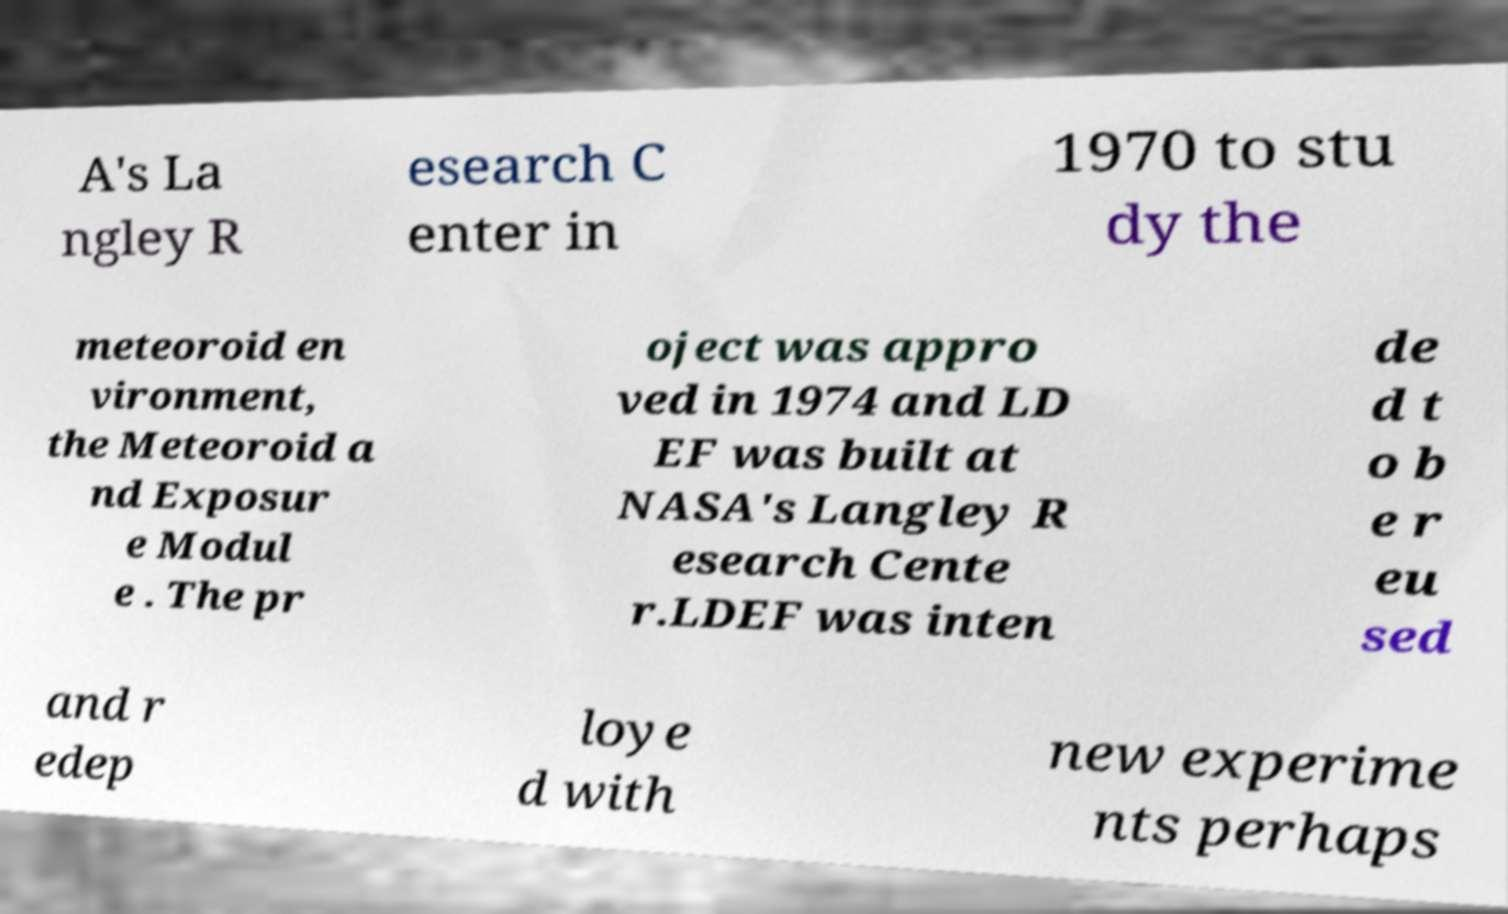For documentation purposes, I need the text within this image transcribed. Could you provide that? A's La ngley R esearch C enter in 1970 to stu dy the meteoroid en vironment, the Meteoroid a nd Exposur e Modul e . The pr oject was appro ved in 1974 and LD EF was built at NASA's Langley R esearch Cente r.LDEF was inten de d t o b e r eu sed and r edep loye d with new experime nts perhaps 